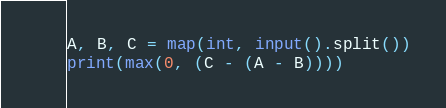Convert code to text. <code><loc_0><loc_0><loc_500><loc_500><_Python_>A, B, C = map(int, input().split())
print(max(0, (C - (A - B))))
</code> 